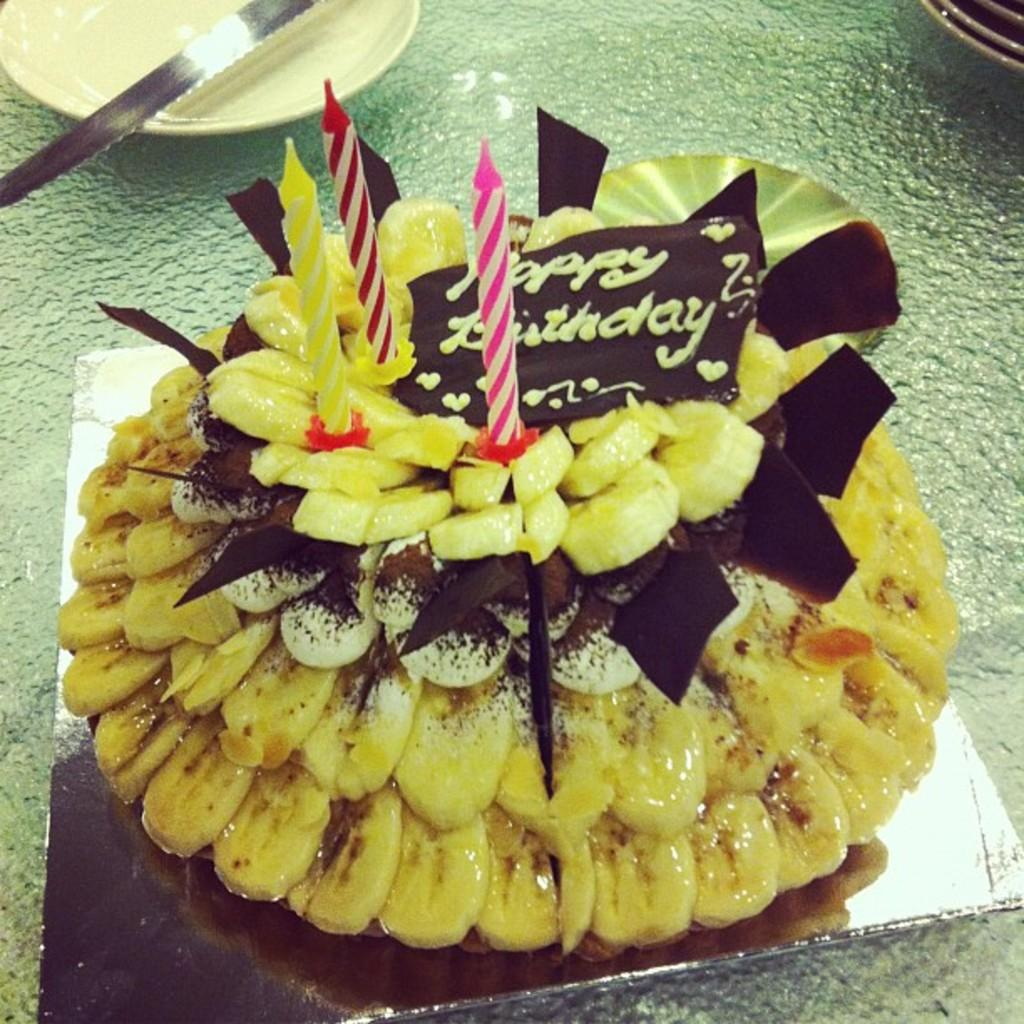What is the main subject in the foreground of the picture? There is a cake in the foreground of the picture. What is placed on the cake? There are candles on the cake. What objects can be seen on the left side of the image? There is a plate and knife on the left side of the image. What objects can be seen on the right side of the image? There are plates on the right side of the image. What word is written on the cake in the image? There is no word written on the cake in the image. What is the carpenter doing in the image? There is no carpenter present in the image. 